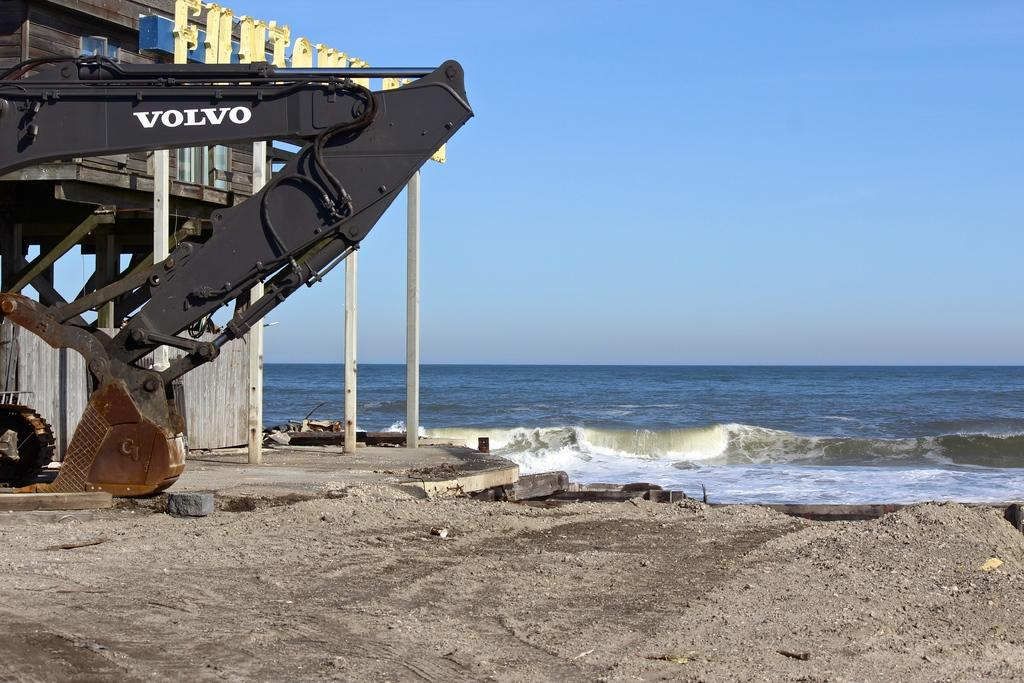What type of natural feature is visible in the image? There is a sea in the image. What structure is located in front of the sea? There is a wooden building in front of the sea. What is the large object beside the building? There is a crane beside the building. What type of terrain is visible on the right side of the image? There is a land covered with sand on the right side of the image. What type of milk is being served in the wooden building? There is no milk or indication of food or drink being served in the wooden building in the image. 